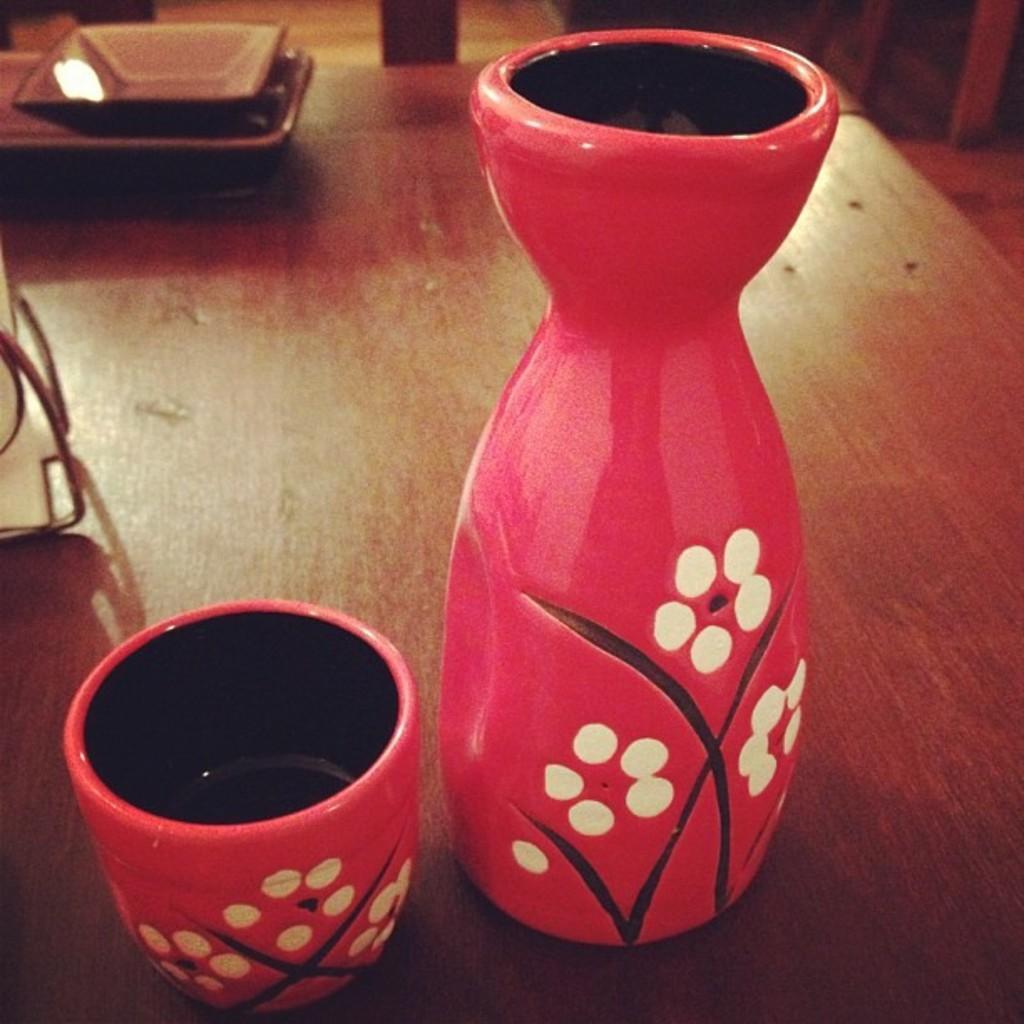Can you describe this image briefly? In this image I can see a red colour cup and a red colour pot. In the background I can see few brown colour things and here I can see a white colour object. 